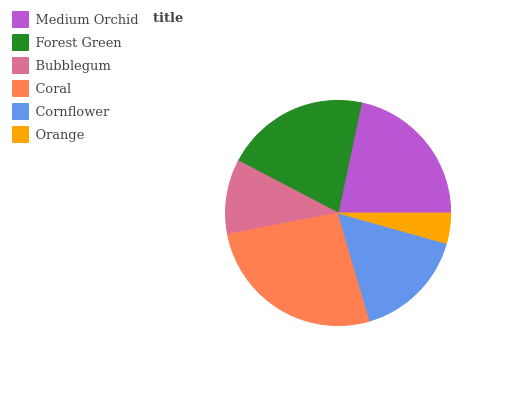Is Orange the minimum?
Answer yes or no. Yes. Is Coral the maximum?
Answer yes or no. Yes. Is Forest Green the minimum?
Answer yes or no. No. Is Forest Green the maximum?
Answer yes or no. No. Is Medium Orchid greater than Forest Green?
Answer yes or no. Yes. Is Forest Green less than Medium Orchid?
Answer yes or no. Yes. Is Forest Green greater than Medium Orchid?
Answer yes or no. No. Is Medium Orchid less than Forest Green?
Answer yes or no. No. Is Forest Green the high median?
Answer yes or no. Yes. Is Cornflower the low median?
Answer yes or no. Yes. Is Medium Orchid the high median?
Answer yes or no. No. Is Forest Green the low median?
Answer yes or no. No. 